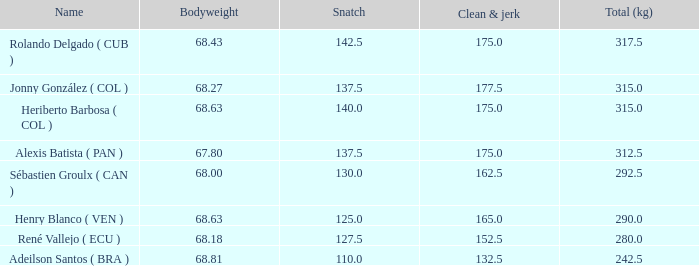5 in clean and jerk when the total kg amounted to 315 and the bodyweight was 6 1.0. 